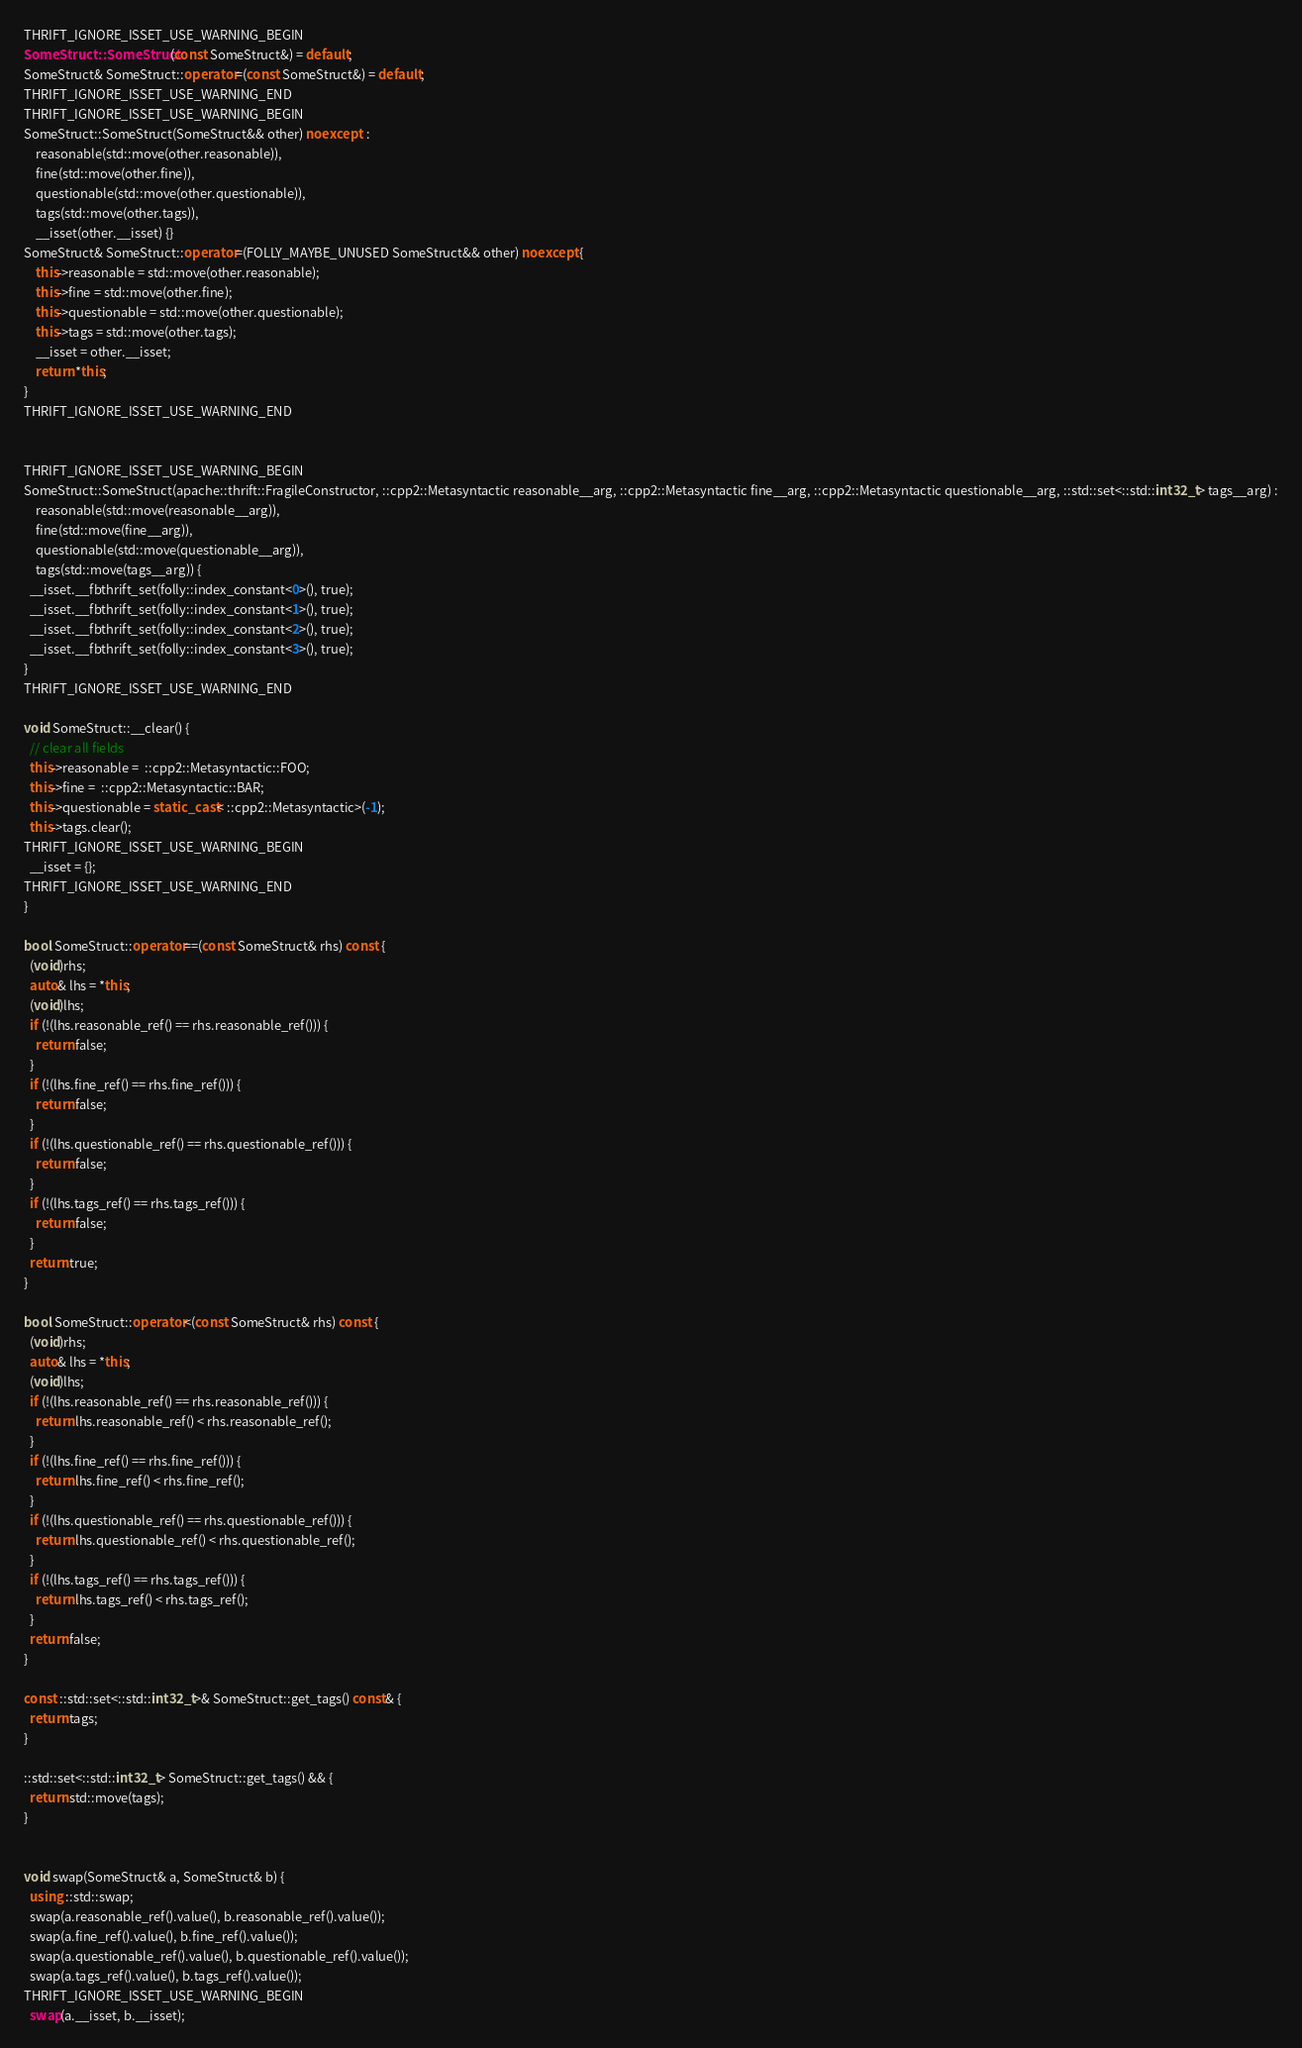Convert code to text. <code><loc_0><loc_0><loc_500><loc_500><_C++_>THRIFT_IGNORE_ISSET_USE_WARNING_BEGIN
SomeStruct::SomeStruct(const SomeStruct&) = default;
SomeStruct& SomeStruct::operator=(const SomeStruct&) = default;
THRIFT_IGNORE_ISSET_USE_WARNING_END
THRIFT_IGNORE_ISSET_USE_WARNING_BEGIN
SomeStruct::SomeStruct(SomeStruct&& other) noexcept  :
    reasonable(std::move(other.reasonable)),
    fine(std::move(other.fine)),
    questionable(std::move(other.questionable)),
    tags(std::move(other.tags)),
    __isset(other.__isset) {}
SomeStruct& SomeStruct::operator=(FOLLY_MAYBE_UNUSED SomeStruct&& other) noexcept {
    this->reasonable = std::move(other.reasonable);
    this->fine = std::move(other.fine);
    this->questionable = std::move(other.questionable);
    this->tags = std::move(other.tags);
    __isset = other.__isset;
    return *this;
}
THRIFT_IGNORE_ISSET_USE_WARNING_END


THRIFT_IGNORE_ISSET_USE_WARNING_BEGIN
SomeStruct::SomeStruct(apache::thrift::FragileConstructor, ::cpp2::Metasyntactic reasonable__arg, ::cpp2::Metasyntactic fine__arg, ::cpp2::Metasyntactic questionable__arg, ::std::set<::std::int32_t> tags__arg) :
    reasonable(std::move(reasonable__arg)),
    fine(std::move(fine__arg)),
    questionable(std::move(questionable__arg)),
    tags(std::move(tags__arg)) {
  __isset.__fbthrift_set(folly::index_constant<0>(), true);
  __isset.__fbthrift_set(folly::index_constant<1>(), true);
  __isset.__fbthrift_set(folly::index_constant<2>(), true);
  __isset.__fbthrift_set(folly::index_constant<3>(), true);
}
THRIFT_IGNORE_ISSET_USE_WARNING_END

void SomeStruct::__clear() {
  // clear all fields
  this->reasonable =  ::cpp2::Metasyntactic::FOO;
  this->fine =  ::cpp2::Metasyntactic::BAR;
  this->questionable = static_cast< ::cpp2::Metasyntactic>(-1);
  this->tags.clear();
THRIFT_IGNORE_ISSET_USE_WARNING_BEGIN
  __isset = {};
THRIFT_IGNORE_ISSET_USE_WARNING_END
}

bool SomeStruct::operator==(const SomeStruct& rhs) const {
  (void)rhs;
  auto& lhs = *this;
  (void)lhs;
  if (!(lhs.reasonable_ref() == rhs.reasonable_ref())) {
    return false;
  }
  if (!(lhs.fine_ref() == rhs.fine_ref())) {
    return false;
  }
  if (!(lhs.questionable_ref() == rhs.questionable_ref())) {
    return false;
  }
  if (!(lhs.tags_ref() == rhs.tags_ref())) {
    return false;
  }
  return true;
}

bool SomeStruct::operator<(const SomeStruct& rhs) const {
  (void)rhs;
  auto& lhs = *this;
  (void)lhs;
  if (!(lhs.reasonable_ref() == rhs.reasonable_ref())) {
    return lhs.reasonable_ref() < rhs.reasonable_ref();
  }
  if (!(lhs.fine_ref() == rhs.fine_ref())) {
    return lhs.fine_ref() < rhs.fine_ref();
  }
  if (!(lhs.questionable_ref() == rhs.questionable_ref())) {
    return lhs.questionable_ref() < rhs.questionable_ref();
  }
  if (!(lhs.tags_ref() == rhs.tags_ref())) {
    return lhs.tags_ref() < rhs.tags_ref();
  }
  return false;
}

const ::std::set<::std::int32_t>& SomeStruct::get_tags() const& {
  return tags;
}

::std::set<::std::int32_t> SomeStruct::get_tags() && {
  return std::move(tags);
}


void swap(SomeStruct& a, SomeStruct& b) {
  using ::std::swap;
  swap(a.reasonable_ref().value(), b.reasonable_ref().value());
  swap(a.fine_ref().value(), b.fine_ref().value());
  swap(a.questionable_ref().value(), b.questionable_ref().value());
  swap(a.tags_ref().value(), b.tags_ref().value());
THRIFT_IGNORE_ISSET_USE_WARNING_BEGIN
  swap(a.__isset, b.__isset);</code> 